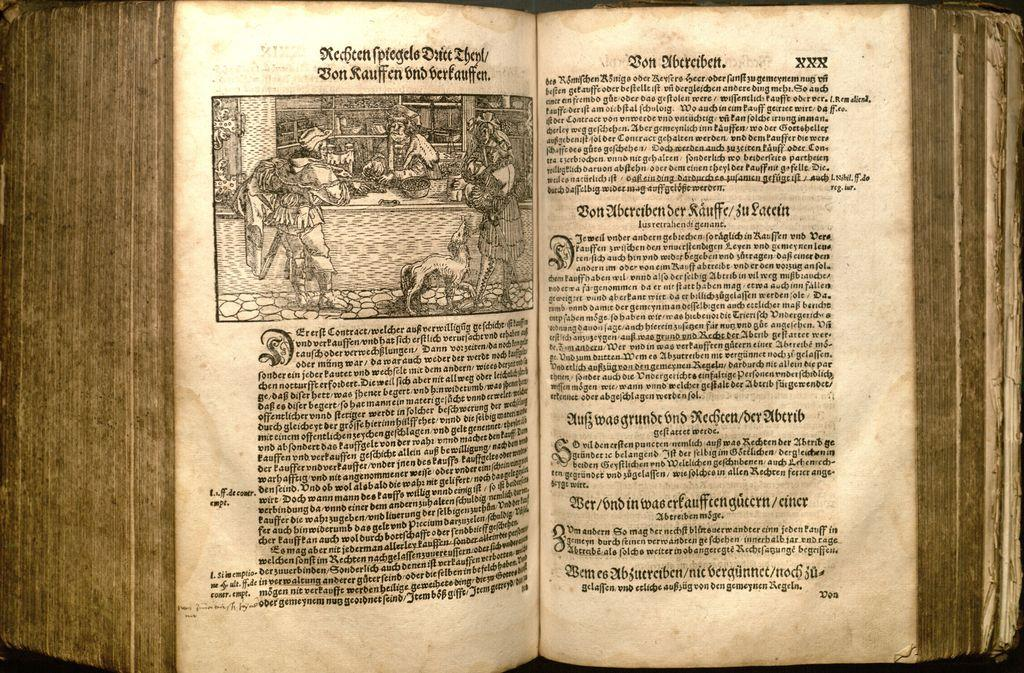<image>
Relay a brief, clear account of the picture shown. an old German tome open to a page with Bon Ubereibett on it 